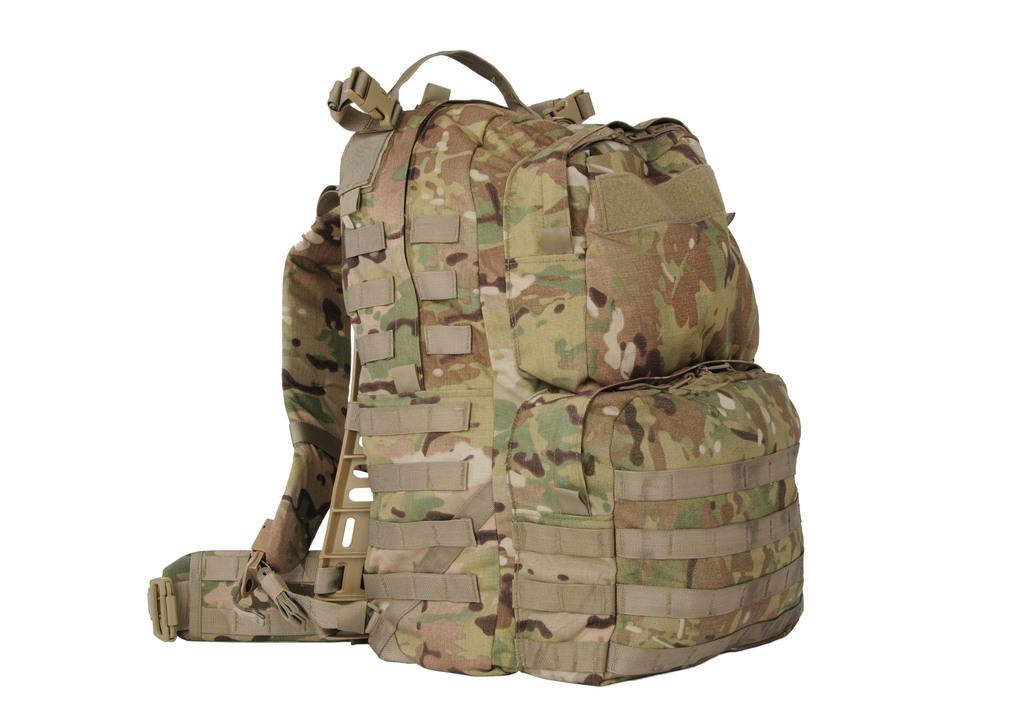What object can be seen in the image? There is a bag in the image. Can you describe the appearance of the bag? The bag has multiple colors. Is there a hill visible in the image? There is no hill present in the image; it only features a bag with multiple colors. 